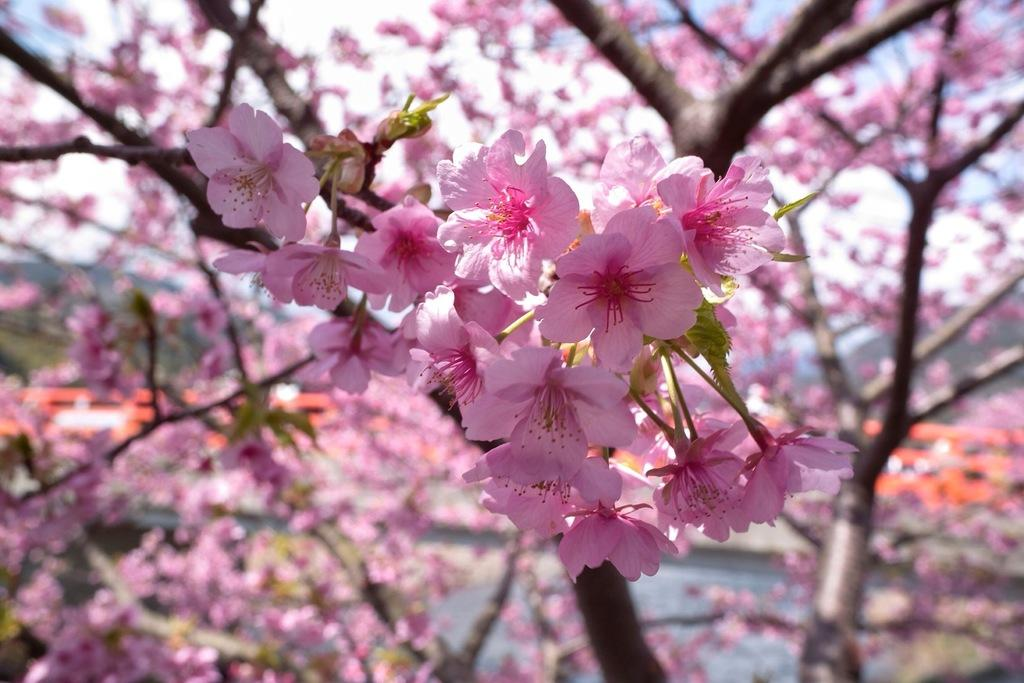What type of flowers can be seen on the tree in the image? There are flowers on a tree in the image, but the specific type of flowers cannot be determined from the provided facts. What can be observed about the background of the image? The background of the image is blurred. How many clubs are visible in the stomach of the tree in the image? There are no clubs or references to a stomach in the image; it features a tree with flowers and a blurred background. 